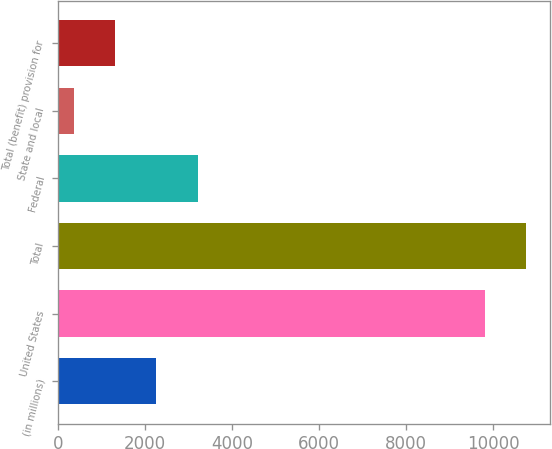<chart> <loc_0><loc_0><loc_500><loc_500><bar_chart><fcel>(in millions)<fcel>United States<fcel>Total<fcel>Federal<fcel>State and local<fcel>Total (benefit) provision for<nl><fcel>2258.4<fcel>9809<fcel>10755.2<fcel>3204.6<fcel>366<fcel>1312.2<nl></chart> 